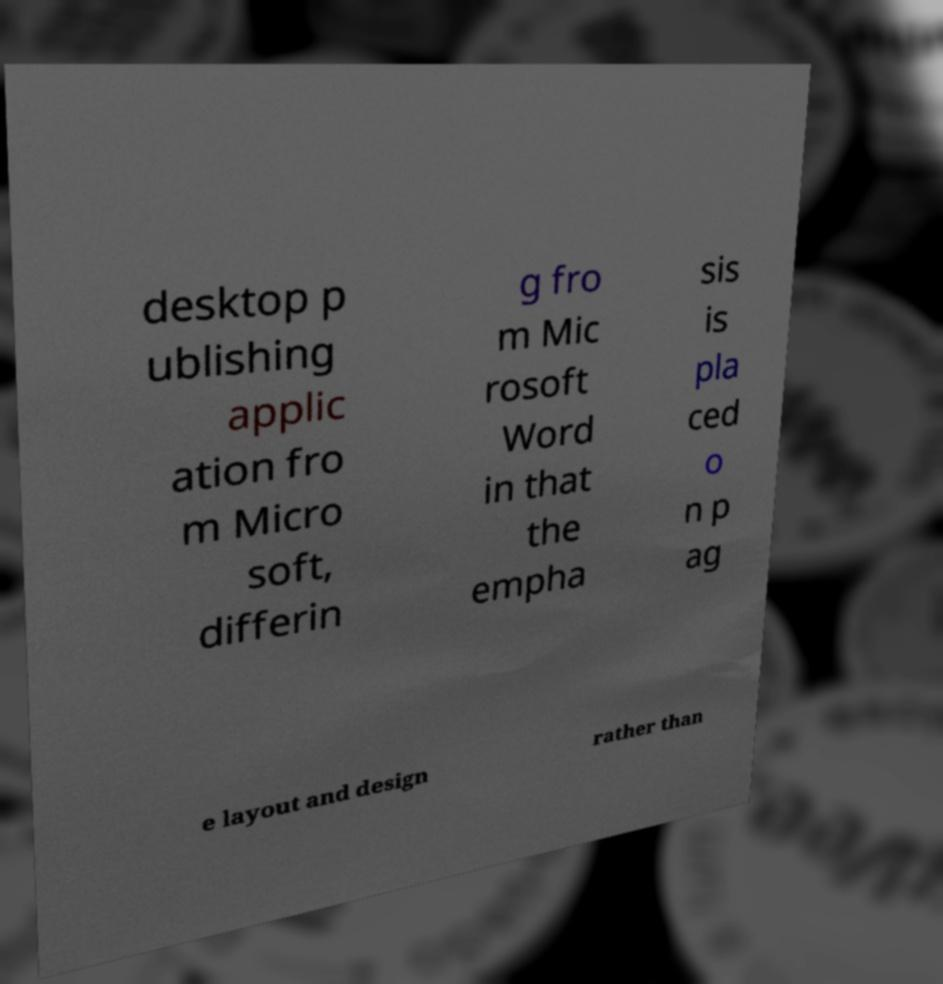Please read and relay the text visible in this image. What does it say? desktop p ublishing applic ation fro m Micro soft, differin g fro m Mic rosoft Word in that the empha sis is pla ced o n p ag e layout and design rather than 